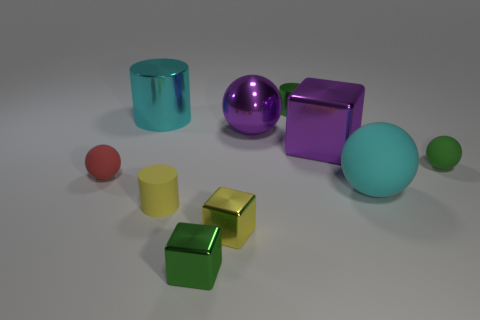How many other objects are the same size as the yellow shiny cube?
Provide a succinct answer. 5. What number of big brown rubber cubes are there?
Make the answer very short. 0. Is there anything else that has the same shape as the cyan rubber object?
Give a very brief answer. Yes. Is the material of the tiny sphere to the right of the yellow matte object the same as the sphere that is on the left side of the big cyan shiny object?
Give a very brief answer. Yes. What is the small green sphere made of?
Make the answer very short. Rubber. What number of small cylinders are made of the same material as the red thing?
Your answer should be compact. 1. What number of metallic objects are either brown cylinders or tiny green cubes?
Offer a terse response. 1. There is a matte thing that is on the left side of the big cylinder; is its shape the same as the green metallic thing that is in front of the big cyan metallic object?
Your response must be concise. No. There is a big object that is right of the yellow matte thing and left of the big purple metallic block; what is its color?
Your answer should be compact. Purple. There is a cyan object right of the green cube; is its size the same as the purple thing behind the large purple metallic cube?
Provide a succinct answer. Yes. 